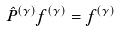Convert formula to latex. <formula><loc_0><loc_0><loc_500><loc_500>\hat { P } ^ { ( \gamma ) } f ^ { ( \gamma ) } = f ^ { ( \gamma ) }</formula> 